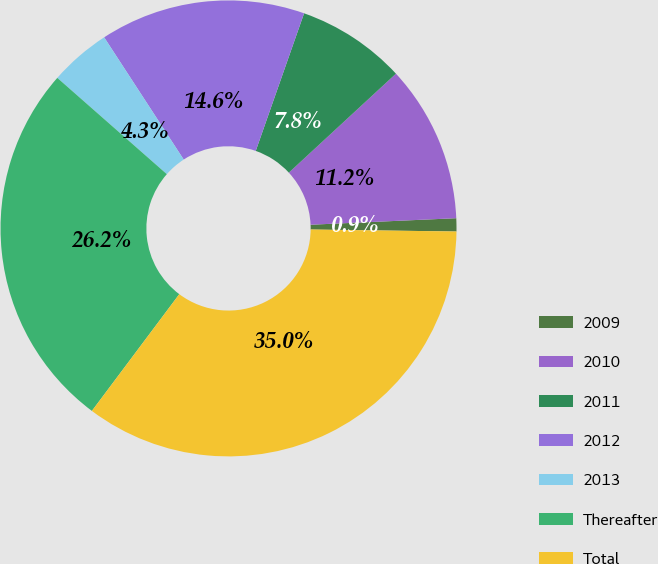Convert chart. <chart><loc_0><loc_0><loc_500><loc_500><pie_chart><fcel>2009<fcel>2010<fcel>2011<fcel>2012<fcel>2013<fcel>Thereafter<fcel>Total<nl><fcel>0.93%<fcel>11.16%<fcel>7.75%<fcel>14.56%<fcel>4.34%<fcel>26.25%<fcel>35.01%<nl></chart> 